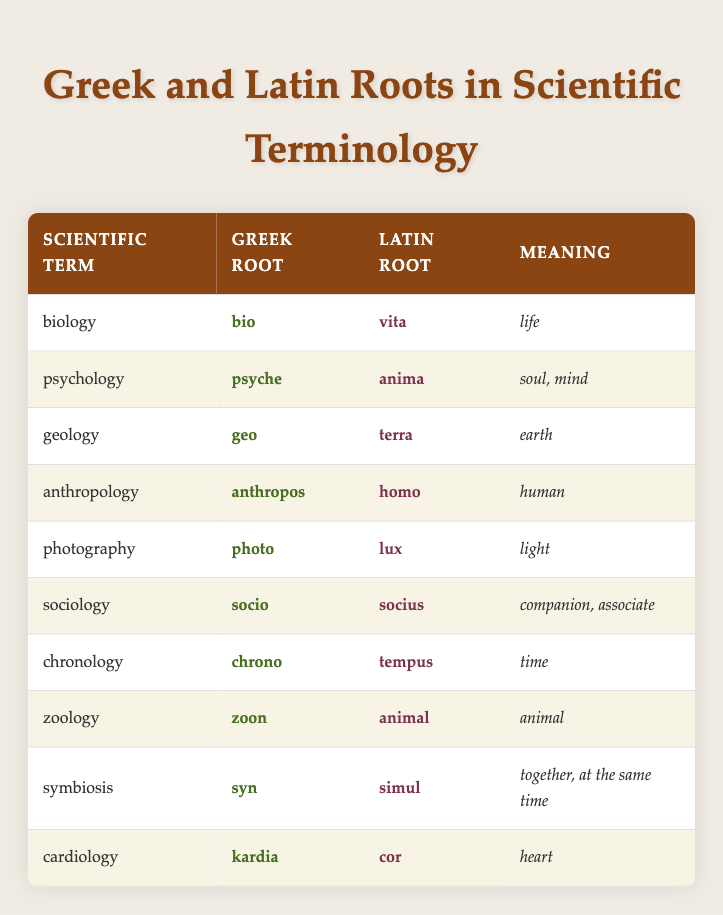What is the Greek root for the term "zoology"? The table lists "zoology" with its Greek root given as "zoon." This value can be found directly in the row corresponding to "zoology."
Answer: zoon Which scientific term has the Latin root "cor"? Referring to the table, the term "cardiology" shows the Latin root "cor" in its corresponding row. This is a straightforward retrieval from the data presented.
Answer: cardiology How many scientific terms in the table contain the Greek root "socio"? The table indicates that "sociology" is the only scientific term listed with the Greek root "socio," which can be directly confirmed by checking the relevant row.
Answer: 1 Is the meaning of "psychology" associated with "soul"? The table provides "soul, mind" as the meaning for the term "psychology." Therefore, the statement is true since this meaning is specifically listed in relation to the term.
Answer: Yes Which term has a meaning related to "together, at the same time"? Looking at the table, the term "symbiosis" corresponds to the meaning "together, at the same time." This can be verified by finding the relevant row and its description.
Answer: symbiosis What is the difference in meanings between "biology" and "geology"? "Biology" means "life," and "geology" means "earth." The difference in meanings indicates contrasting subjects in the sciences, as biology pertains to living organisms while geology pertains to the planet. Thus, the concepts are distinctly different.
Answer: different How many terms in the table refer to entities related to life or living beings? The terms "biology," "zoology," and "psychology" can be identified in the table, associated with life. To determine the total, one counts these terms which specifically reference concepts of life or soul. The count results in three.
Answer: 3 Which root is common between "sociology" and "psychology"? The table reveals that both terms utilize the Greek root involving social constructs—specifically "socio" in "sociology" and "psyche" in "psychology" with the meaning related to companionship or mind, but they stem from different roots. Thus, the specifics do not share a common root.
Answer: No common root 